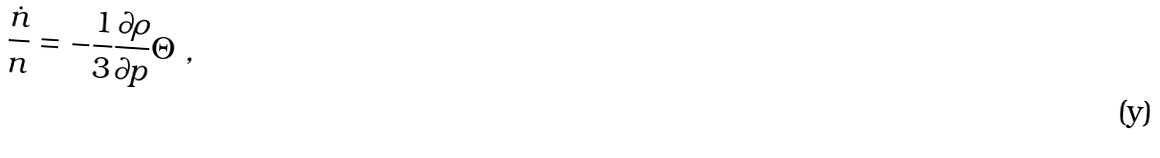<formula> <loc_0><loc_0><loc_500><loc_500>\frac { \dot { n } } { n } = - \frac { 1 } { 3 } \frac { \partial { \rho } } { \partial { p } } \Theta \ ,</formula> 